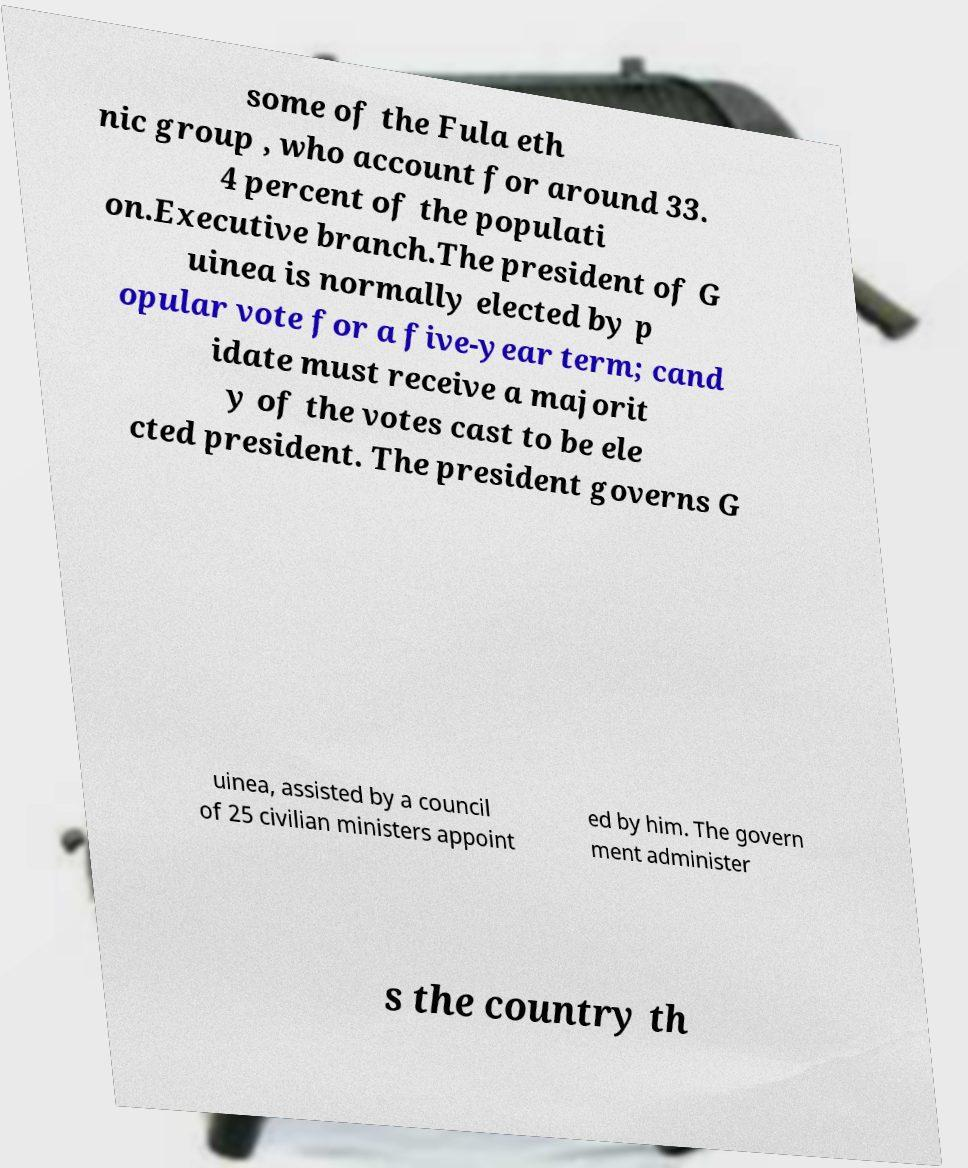Can you accurately transcribe the text from the provided image for me? some of the Fula eth nic group , who account for around 33. 4 percent of the populati on.Executive branch.The president of G uinea is normally elected by p opular vote for a five-year term; cand idate must receive a majorit y of the votes cast to be ele cted president. The president governs G uinea, assisted by a council of 25 civilian ministers appoint ed by him. The govern ment administer s the country th 